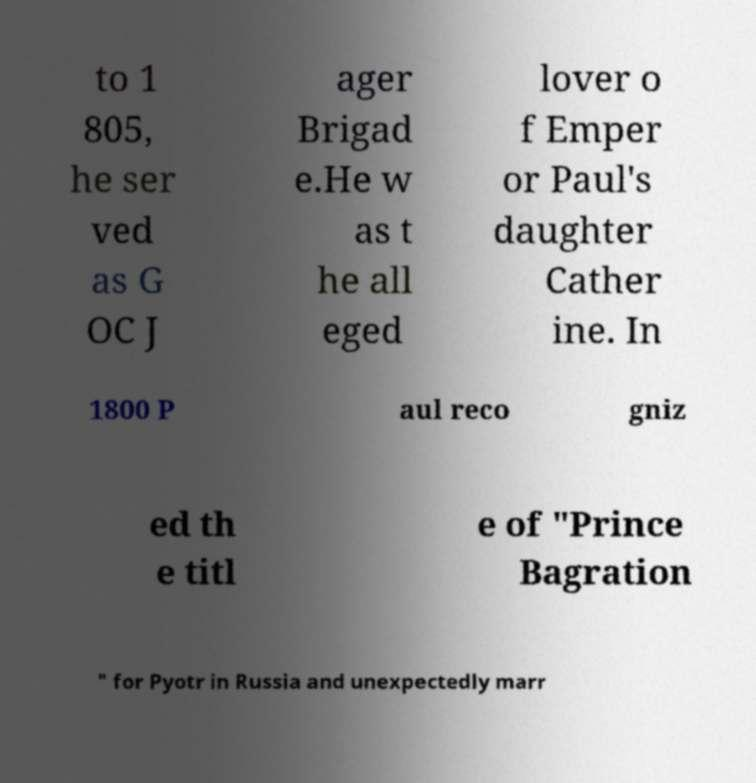What messages or text are displayed in this image? I need them in a readable, typed format. to 1 805, he ser ved as G OC J ager Brigad e.He w as t he all eged lover o f Emper or Paul's daughter Cather ine. In 1800 P aul reco gniz ed th e titl e of "Prince Bagration " for Pyotr in Russia and unexpectedly marr 